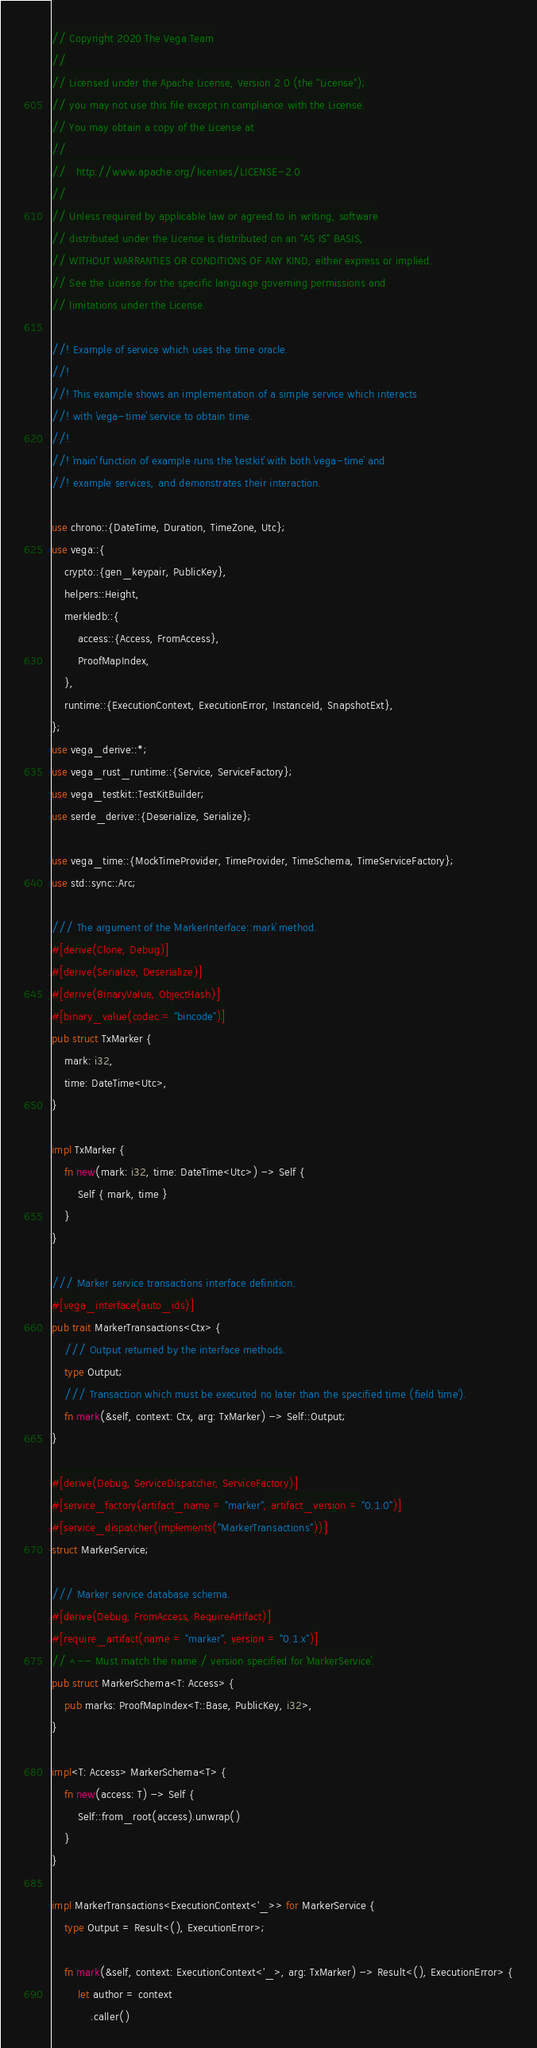<code> <loc_0><loc_0><loc_500><loc_500><_Rust_>// Copyright 2020 The Vega Team
//
// Licensed under the Apache License, Version 2.0 (the "License");
// you may not use this file except in compliance with the License.
// You may obtain a copy of the License at
//
//   http://www.apache.org/licenses/LICENSE-2.0
//
// Unless required by applicable law or agreed to in writing, software
// distributed under the License is distributed on an "AS IS" BASIS,
// WITHOUT WARRANTIES OR CONDITIONS OF ANY KIND, either express or implied.
// See the License for the specific language governing permissions and
// limitations under the License.

//! Example of service which uses the time oracle.
//!
//! This example shows an implementation of a simple service which interacts
//! with `vega-time` service to obtain time.
//!
//! `main` function of example runs the `testkit` with both `vega-time` and
//! example services, and demonstrates their interaction.

use chrono::{DateTime, Duration, TimeZone, Utc};
use vega::{
    crypto::{gen_keypair, PublicKey},
    helpers::Height,
    merkledb::{
        access::{Access, FromAccess},
        ProofMapIndex,
    },
    runtime::{ExecutionContext, ExecutionError, InstanceId, SnapshotExt},
};
use vega_derive::*;
use vega_rust_runtime::{Service, ServiceFactory};
use vega_testkit::TestKitBuilder;
use serde_derive::{Deserialize, Serialize};

use vega_time::{MockTimeProvider, TimeProvider, TimeSchema, TimeServiceFactory};
use std::sync::Arc;

/// The argument of the `MarkerInterface::mark` method.
#[derive(Clone, Debug)]
#[derive(Serialize, Deserialize)]
#[derive(BinaryValue, ObjectHash)]
#[binary_value(codec = "bincode")]
pub struct TxMarker {
    mark: i32,
    time: DateTime<Utc>,
}

impl TxMarker {
    fn new(mark: i32, time: DateTime<Utc>) -> Self {
        Self { mark, time }
    }
}

/// Marker service transactions interface definition.
#[vega_interface(auto_ids)]
pub trait MarkerTransactions<Ctx> {
    /// Output returned by the interface methods.
    type Output;
    /// Transaction which must be executed no later than the specified time (field `time`).
    fn mark(&self, context: Ctx, arg: TxMarker) -> Self::Output;
}

#[derive(Debug, ServiceDispatcher, ServiceFactory)]
#[service_factory(artifact_name = "marker", artifact_version = "0.1.0")]
#[service_dispatcher(implements("MarkerTransactions"))]
struct MarkerService;

/// Marker service database schema.
#[derive(Debug, FromAccess, RequireArtifact)]
#[require_artifact(name = "marker", version = "0.1.x")]
// ^-- Must match the name / version specified for `MarkerService`.
pub struct MarkerSchema<T: Access> {
    pub marks: ProofMapIndex<T::Base, PublicKey, i32>,
}

impl<T: Access> MarkerSchema<T> {
    fn new(access: T) -> Self {
        Self::from_root(access).unwrap()
    }
}

impl MarkerTransactions<ExecutionContext<'_>> for MarkerService {
    type Output = Result<(), ExecutionError>;

    fn mark(&self, context: ExecutionContext<'_>, arg: TxMarker) -> Result<(), ExecutionError> {
        let author = context
            .caller()</code> 